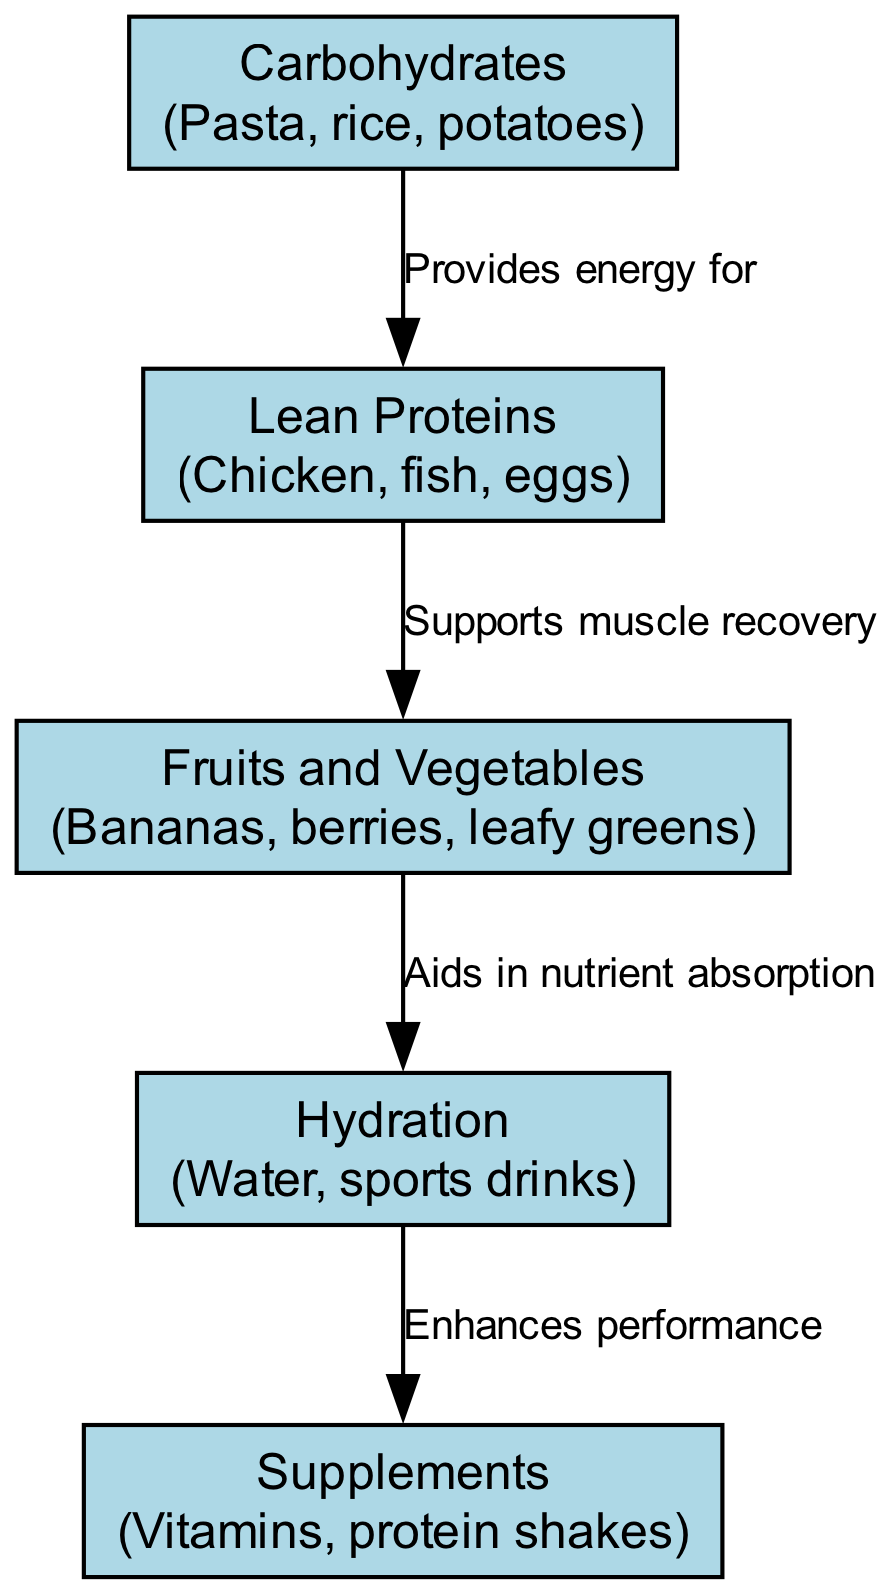What is the first node in the diagram? The first node in the diagram represents "Carbohydrates," which is at the top of the hierarchy.
Answer: Carbohydrates How many nodes are there in total? By counting the nodes listed in the data, there are five distinct nutritional categories presented in the diagram.
Answer: 5 Which node provides energy for Lean Proteins? The edge labeled "Provides energy for" connects "Carbohydrates" to "Lean Proteins," indicating that carbohydrates supply energy needed for proteins.
Answer: Carbohydrates What is the relationship between Fruits and Vegetables and Hydration? The edge connects "Fruits and Vegetables" to "Hydration" with the label "Aids in nutrient absorption," showing that fruits and vegetables support hydration in nutrient absorption.
Answer: Aids in nutrient absorption What specifically enhances performance according to the diagram? "Hydration" is connected to "Supplements" with the label "Enhances performance," indicating that proper hydration contributes to the performance benefits gained from supplements.
Answer: Supplements Which category is crucial for muscle recovery? "Lean Proteins" is identified as supporting muscle recovery, which is explicitly mentioned in the diagram between the nodes.
Answer: Lean Proteins What is the primary source of nutrient absorption assistance? The diagram shows that "Fruits and Vegetables" aids in nutrient absorption, as denoted by its direct link to "Hydration."
Answer: Fruits and Vegetables What type of drink is associated with hydration in the golfer's diet? "Sports drinks" are included in the "Hydration" category, which indicates that they are part of the hydration strategy for golfers.
Answer: Sports drinks Which two categories are directly connected through a supportive edge? "Lean Proteins" and "Fruits and Vegetables" are directly linked, with the arrow indicating that proteins support the recovery facilitated by vitamins and minerals present in fruits and vegetables.
Answer: Lean Proteins and Fruits and Vegetables 